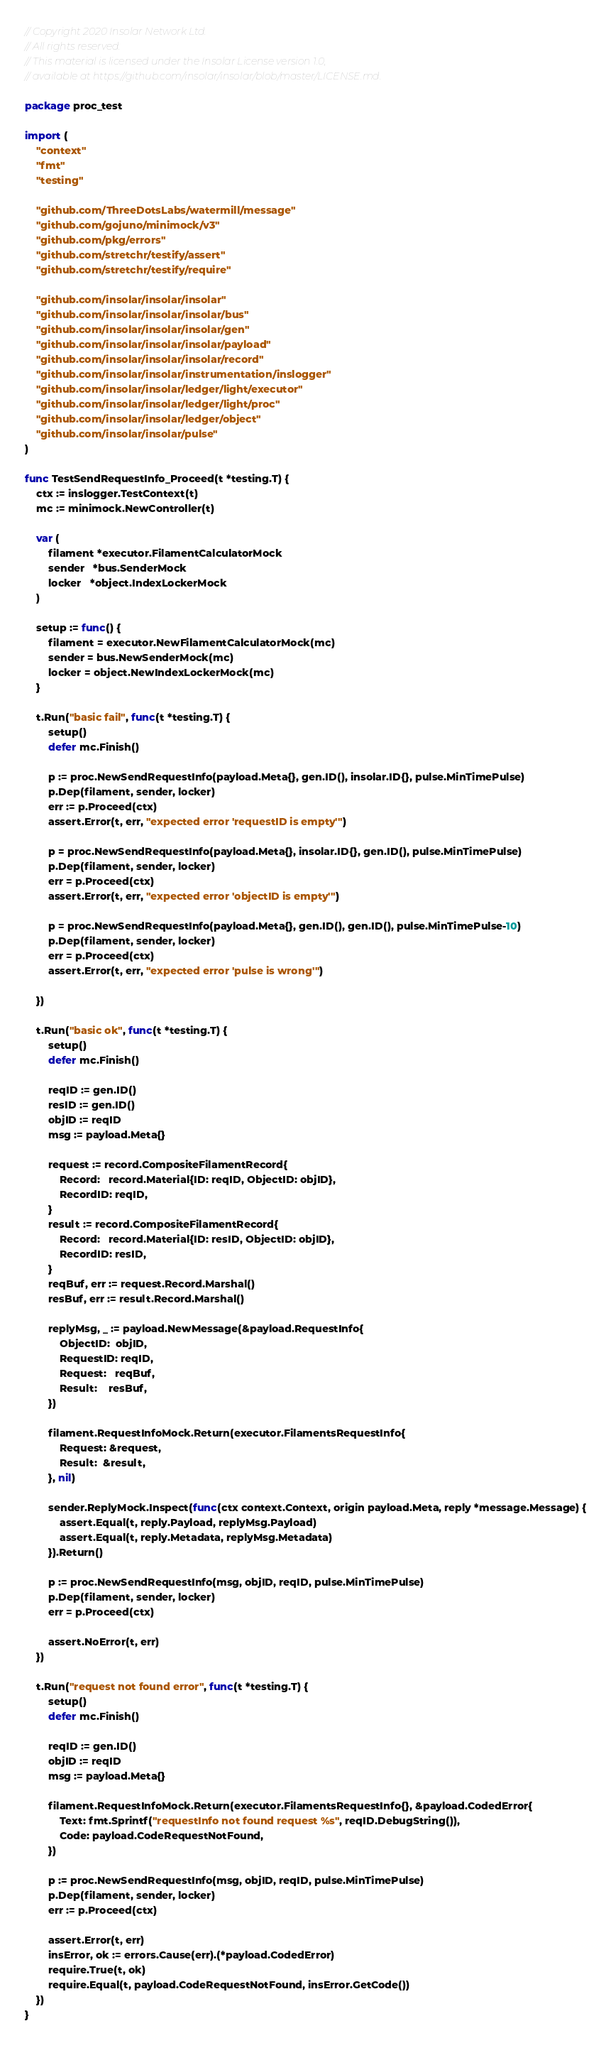Convert code to text. <code><loc_0><loc_0><loc_500><loc_500><_Go_>// Copyright 2020 Insolar Network Ltd.
// All rights reserved.
// This material is licensed under the Insolar License version 1.0,
// available at https://github.com/insolar/insolar/blob/master/LICENSE.md.

package proc_test

import (
	"context"
	"fmt"
	"testing"

	"github.com/ThreeDotsLabs/watermill/message"
	"github.com/gojuno/minimock/v3"
	"github.com/pkg/errors"
	"github.com/stretchr/testify/assert"
	"github.com/stretchr/testify/require"

	"github.com/insolar/insolar/insolar"
	"github.com/insolar/insolar/insolar/bus"
	"github.com/insolar/insolar/insolar/gen"
	"github.com/insolar/insolar/insolar/payload"
	"github.com/insolar/insolar/insolar/record"
	"github.com/insolar/insolar/instrumentation/inslogger"
	"github.com/insolar/insolar/ledger/light/executor"
	"github.com/insolar/insolar/ledger/light/proc"
	"github.com/insolar/insolar/ledger/object"
	"github.com/insolar/insolar/pulse"
)

func TestSendRequestInfo_Proceed(t *testing.T) {
	ctx := inslogger.TestContext(t)
	mc := minimock.NewController(t)

	var (
		filament *executor.FilamentCalculatorMock
		sender   *bus.SenderMock
		locker   *object.IndexLockerMock
	)

	setup := func() {
		filament = executor.NewFilamentCalculatorMock(mc)
		sender = bus.NewSenderMock(mc)
		locker = object.NewIndexLockerMock(mc)
	}

	t.Run("basic fail", func(t *testing.T) {
		setup()
		defer mc.Finish()

		p := proc.NewSendRequestInfo(payload.Meta{}, gen.ID(), insolar.ID{}, pulse.MinTimePulse)
		p.Dep(filament, sender, locker)
		err := p.Proceed(ctx)
		assert.Error(t, err, "expected error 'requestID is empty'")

		p = proc.NewSendRequestInfo(payload.Meta{}, insolar.ID{}, gen.ID(), pulse.MinTimePulse)
		p.Dep(filament, sender, locker)
		err = p.Proceed(ctx)
		assert.Error(t, err, "expected error 'objectID is empty'")

		p = proc.NewSendRequestInfo(payload.Meta{}, gen.ID(), gen.ID(), pulse.MinTimePulse-10)
		p.Dep(filament, sender, locker)
		err = p.Proceed(ctx)
		assert.Error(t, err, "expected error 'pulse is wrong'")

	})

	t.Run("basic ok", func(t *testing.T) {
		setup()
		defer mc.Finish()

		reqID := gen.ID()
		resID := gen.ID()
		objID := reqID
		msg := payload.Meta{}

		request := record.CompositeFilamentRecord{
			Record:   record.Material{ID: reqID, ObjectID: objID},
			RecordID: reqID,
		}
		result := record.CompositeFilamentRecord{
			Record:   record.Material{ID: resID, ObjectID: objID},
			RecordID: resID,
		}
		reqBuf, err := request.Record.Marshal()
		resBuf, err := result.Record.Marshal()

		replyMsg, _ := payload.NewMessage(&payload.RequestInfo{
			ObjectID:  objID,
			RequestID: reqID,
			Request:   reqBuf,
			Result:    resBuf,
		})

		filament.RequestInfoMock.Return(executor.FilamentsRequestInfo{
			Request: &request,
			Result:  &result,
		}, nil)

		sender.ReplyMock.Inspect(func(ctx context.Context, origin payload.Meta, reply *message.Message) {
			assert.Equal(t, reply.Payload, replyMsg.Payload)
			assert.Equal(t, reply.Metadata, replyMsg.Metadata)
		}).Return()

		p := proc.NewSendRequestInfo(msg, objID, reqID, pulse.MinTimePulse)
		p.Dep(filament, sender, locker)
		err = p.Proceed(ctx)

		assert.NoError(t, err)
	})

	t.Run("request not found error", func(t *testing.T) {
		setup()
		defer mc.Finish()

		reqID := gen.ID()
		objID := reqID
		msg := payload.Meta{}

		filament.RequestInfoMock.Return(executor.FilamentsRequestInfo{}, &payload.CodedError{
			Text: fmt.Sprintf("requestInfo not found request %s", reqID.DebugString()),
			Code: payload.CodeRequestNotFound,
		})

		p := proc.NewSendRequestInfo(msg, objID, reqID, pulse.MinTimePulse)
		p.Dep(filament, sender, locker)
		err := p.Proceed(ctx)

		assert.Error(t, err)
		insError, ok := errors.Cause(err).(*payload.CodedError)
		require.True(t, ok)
		require.Equal(t, payload.CodeRequestNotFound, insError.GetCode())
	})
}
</code> 